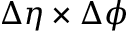Convert formula to latex. <formula><loc_0><loc_0><loc_500><loc_500>\Delta \eta \times \Delta \phi</formula> 